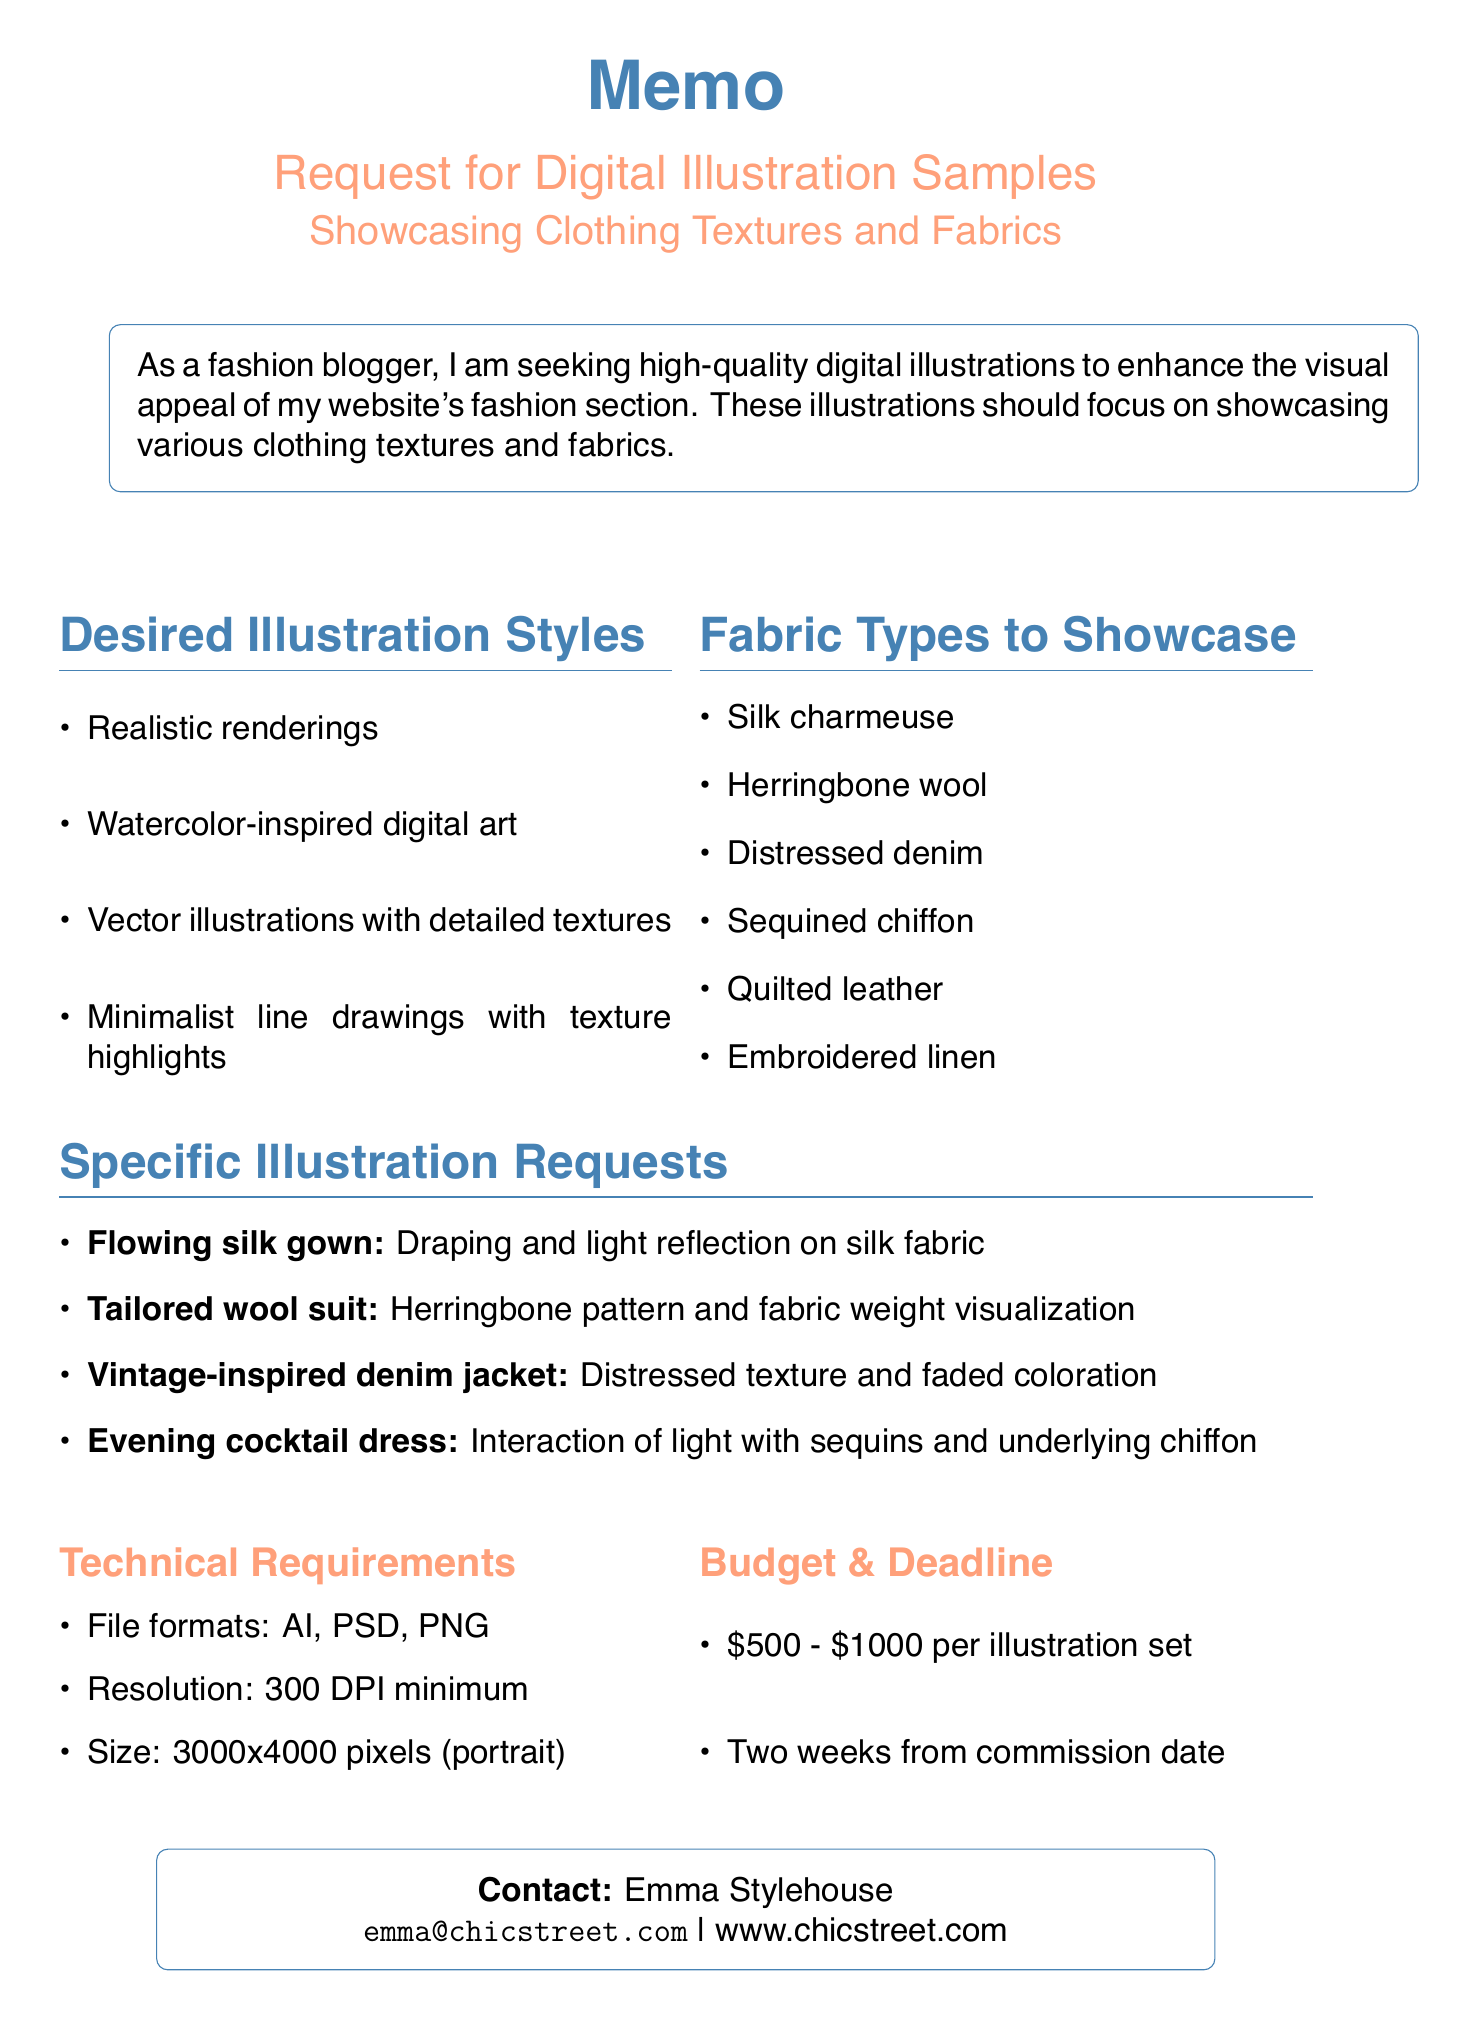What is the memo title? The memo title clearly states the purpose of the document, which is "Request for Digital Illustration Samples: Showcasing Clothing Textures and Fabrics."
Answer: Request for Digital Illustration Samples: Showcasing Clothing Textures and Fabrics Who is the contact person for this request? The contact information section provides the name of the person making the request, which is listed as Emma Stylehouse.
Answer: Emma Stylehouse What is the budget range mentioned in the memo? The memo explicitly states that the budget range for each illustration set is between $500 and $1000.
Answer: $500 - $1000 What is the deadline for the illustration samples? The memo indicates that the deadline for the requested illustrations is two weeks from the date of commission.
Answer: Two weeks How many desired illustration styles are listed? The document provides a list of four desired illustration styles focusing on different artistic approaches.
Answer: Four What fabric type is specifically requested to showcase draping and light reflection? The specific illustration request highlights that the flowing silk gown should focus on draping and light reflection.
Answer: Silk charmeuse Which two color palettes are preferred for spring/summer looks? The document mentions that soft pastels are the desired color palette for spring/summer collections.
Answer: Soft pastels What technical resolution is specified for the illustrations? The memo specifies that the illustrations need to be at least 300 DPI in resolution for quality purposes.
Answer: 300 DPI minimum Which illustration focuses on herringbone pattern? The specific illustration request identifies the tailored wool suit to visualize the herringbone pattern.
Answer: Tailored wool suit 